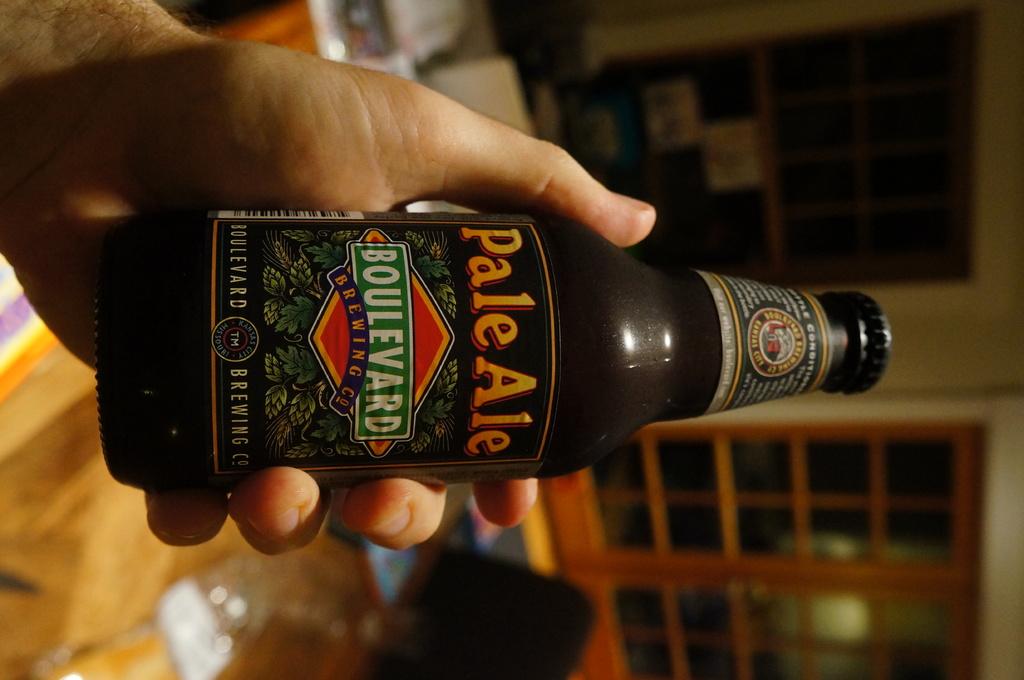What is the name of the brewing company that makes this beer?
Keep it short and to the point. Boulevard. What kind of ale is this?
Give a very brief answer. Pale. 